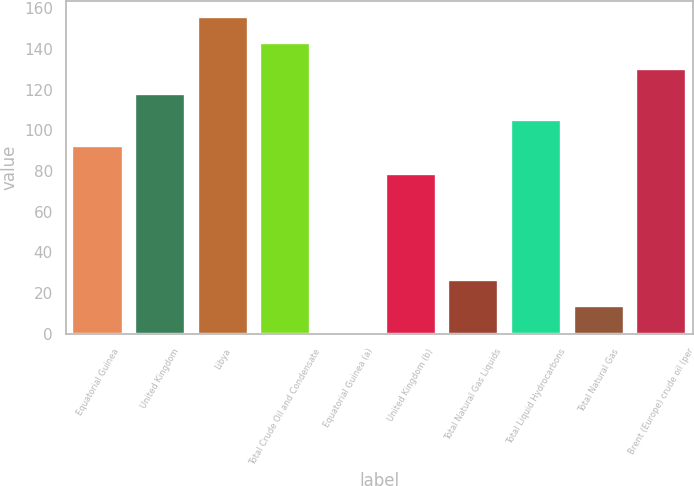<chart> <loc_0><loc_0><loc_500><loc_500><bar_chart><fcel>Equatorial Guinea<fcel>United Kingdom<fcel>Libya<fcel>Total Crude Oil and Condensate<fcel>Equatorial Guinea (a)<fcel>United Kingdom (b)<fcel>Total Natural Gas Liquids<fcel>Total Liquid Hydrocarbons<fcel>Total Natural Gas<fcel>Brent (Europe) crude oil (per<nl><fcel>92.56<fcel>117.82<fcel>155.71<fcel>143.08<fcel>1<fcel>78.81<fcel>26.26<fcel>105.19<fcel>13.63<fcel>130.45<nl></chart> 